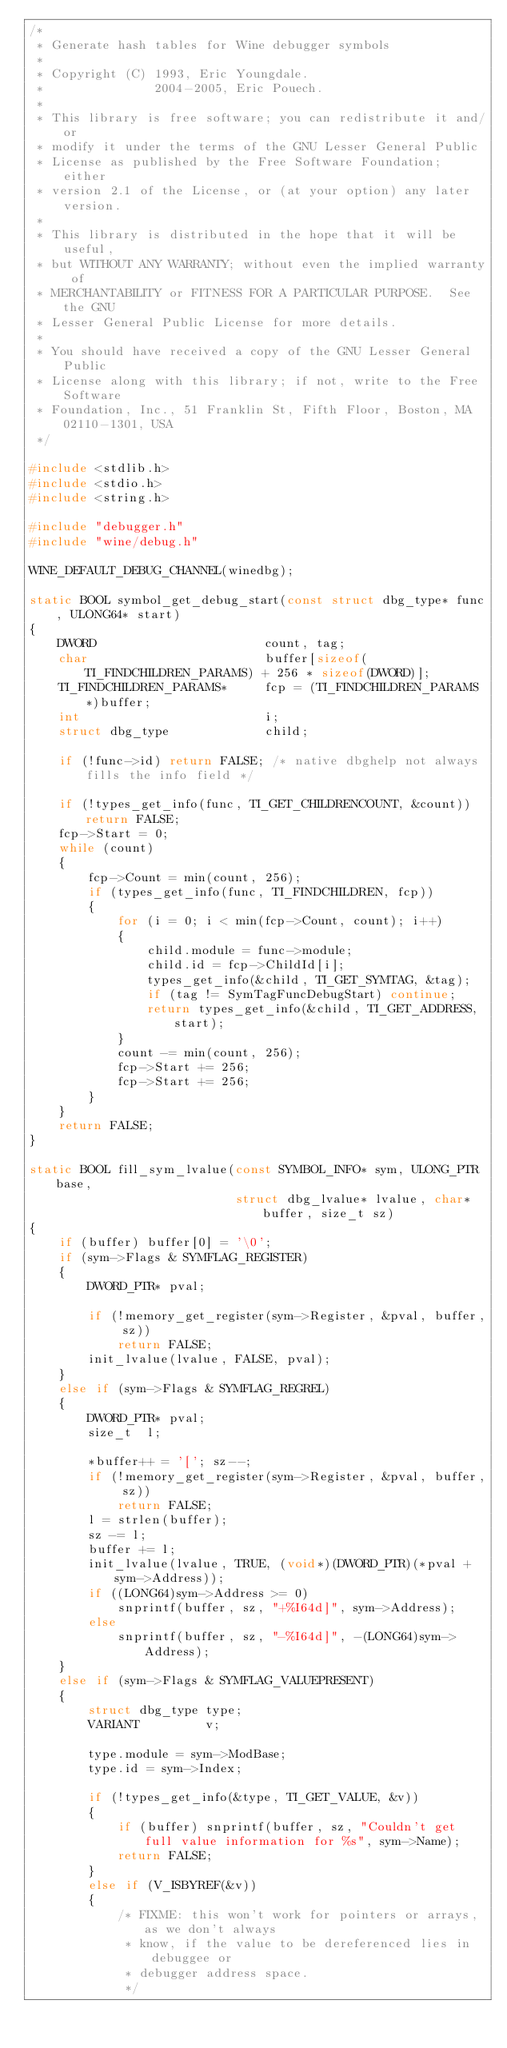Convert code to text. <code><loc_0><loc_0><loc_500><loc_500><_C_>/*
 * Generate hash tables for Wine debugger symbols
 *
 * Copyright (C) 1993, Eric Youngdale.
 *               2004-2005, Eric Pouech.
 *
 * This library is free software; you can redistribute it and/or
 * modify it under the terms of the GNU Lesser General Public
 * License as published by the Free Software Foundation; either
 * version 2.1 of the License, or (at your option) any later version.
 *
 * This library is distributed in the hope that it will be useful,
 * but WITHOUT ANY WARRANTY; without even the implied warranty of
 * MERCHANTABILITY or FITNESS FOR A PARTICULAR PURPOSE.  See the GNU
 * Lesser General Public License for more details.
 *
 * You should have received a copy of the GNU Lesser General Public
 * License along with this library; if not, write to the Free Software
 * Foundation, Inc., 51 Franklin St, Fifth Floor, Boston, MA 02110-1301, USA
 */

#include <stdlib.h>
#include <stdio.h>
#include <string.h>

#include "debugger.h"
#include "wine/debug.h"

WINE_DEFAULT_DEBUG_CHANNEL(winedbg);

static BOOL symbol_get_debug_start(const struct dbg_type* func, ULONG64* start)
{
    DWORD                       count, tag;
    char                        buffer[sizeof(TI_FINDCHILDREN_PARAMS) + 256 * sizeof(DWORD)];
    TI_FINDCHILDREN_PARAMS*     fcp = (TI_FINDCHILDREN_PARAMS*)buffer;
    int                         i;
    struct dbg_type             child;

    if (!func->id) return FALSE; /* native dbghelp not always fills the info field */

    if (!types_get_info(func, TI_GET_CHILDRENCOUNT, &count)) return FALSE;
    fcp->Start = 0;
    while (count)
    {
        fcp->Count = min(count, 256);
        if (types_get_info(func, TI_FINDCHILDREN, fcp))
        {
            for (i = 0; i < min(fcp->Count, count); i++)
            {
                child.module = func->module;
                child.id = fcp->ChildId[i];
                types_get_info(&child, TI_GET_SYMTAG, &tag);
                if (tag != SymTagFuncDebugStart) continue;
                return types_get_info(&child, TI_GET_ADDRESS, start);
            }
            count -= min(count, 256);
            fcp->Start += 256;
            fcp->Start += 256;
        }
    }
    return FALSE;
}

static BOOL fill_sym_lvalue(const SYMBOL_INFO* sym, ULONG_PTR base,
                            struct dbg_lvalue* lvalue, char* buffer, size_t sz)
{
    if (buffer) buffer[0] = '\0';
    if (sym->Flags & SYMFLAG_REGISTER)
    {
        DWORD_PTR* pval;

        if (!memory_get_register(sym->Register, &pval, buffer, sz))
            return FALSE;
        init_lvalue(lvalue, FALSE, pval);
    }
    else if (sym->Flags & SYMFLAG_REGREL)
    {
        DWORD_PTR* pval;
        size_t  l;

        *buffer++ = '['; sz--;
        if (!memory_get_register(sym->Register, &pval, buffer, sz))
            return FALSE;
        l = strlen(buffer);
        sz -= l;
        buffer += l;
        init_lvalue(lvalue, TRUE, (void*)(DWORD_PTR)(*pval + sym->Address));
        if ((LONG64)sym->Address >= 0)
            snprintf(buffer, sz, "+%I64d]", sym->Address);
        else
            snprintf(buffer, sz, "-%I64d]", -(LONG64)sym->Address);
    }
    else if (sym->Flags & SYMFLAG_VALUEPRESENT)
    {
        struct dbg_type type;
        VARIANT         v;

        type.module = sym->ModBase;
        type.id = sym->Index;

        if (!types_get_info(&type, TI_GET_VALUE, &v))
        {
            if (buffer) snprintf(buffer, sz, "Couldn't get full value information for %s", sym->Name);
            return FALSE;
        }
        else if (V_ISBYREF(&v))
        {
            /* FIXME: this won't work for pointers or arrays, as we don't always
             * know, if the value to be dereferenced lies in debuggee or
             * debugger address space.
             */</code> 